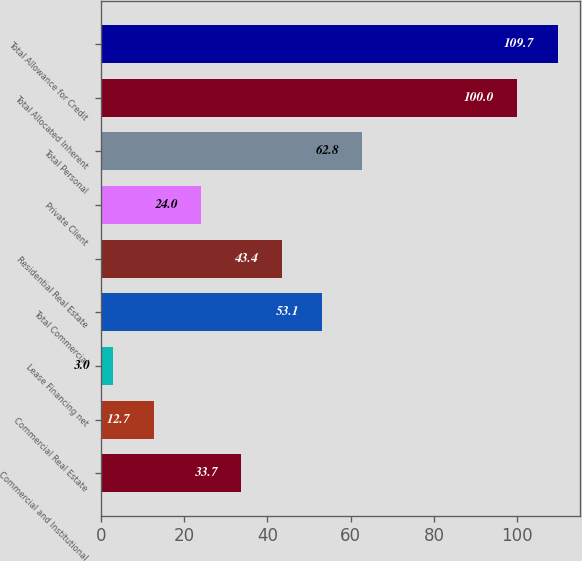<chart> <loc_0><loc_0><loc_500><loc_500><bar_chart><fcel>Commercial and Institutional<fcel>Commercial Real Estate<fcel>Lease Financing net<fcel>Total Commercial<fcel>Residential Real Estate<fcel>Private Client<fcel>Total Personal<fcel>Total Allocated Inherent<fcel>Total Allowance for Credit<nl><fcel>33.7<fcel>12.7<fcel>3<fcel>53.1<fcel>43.4<fcel>24<fcel>62.8<fcel>100<fcel>109.7<nl></chart> 